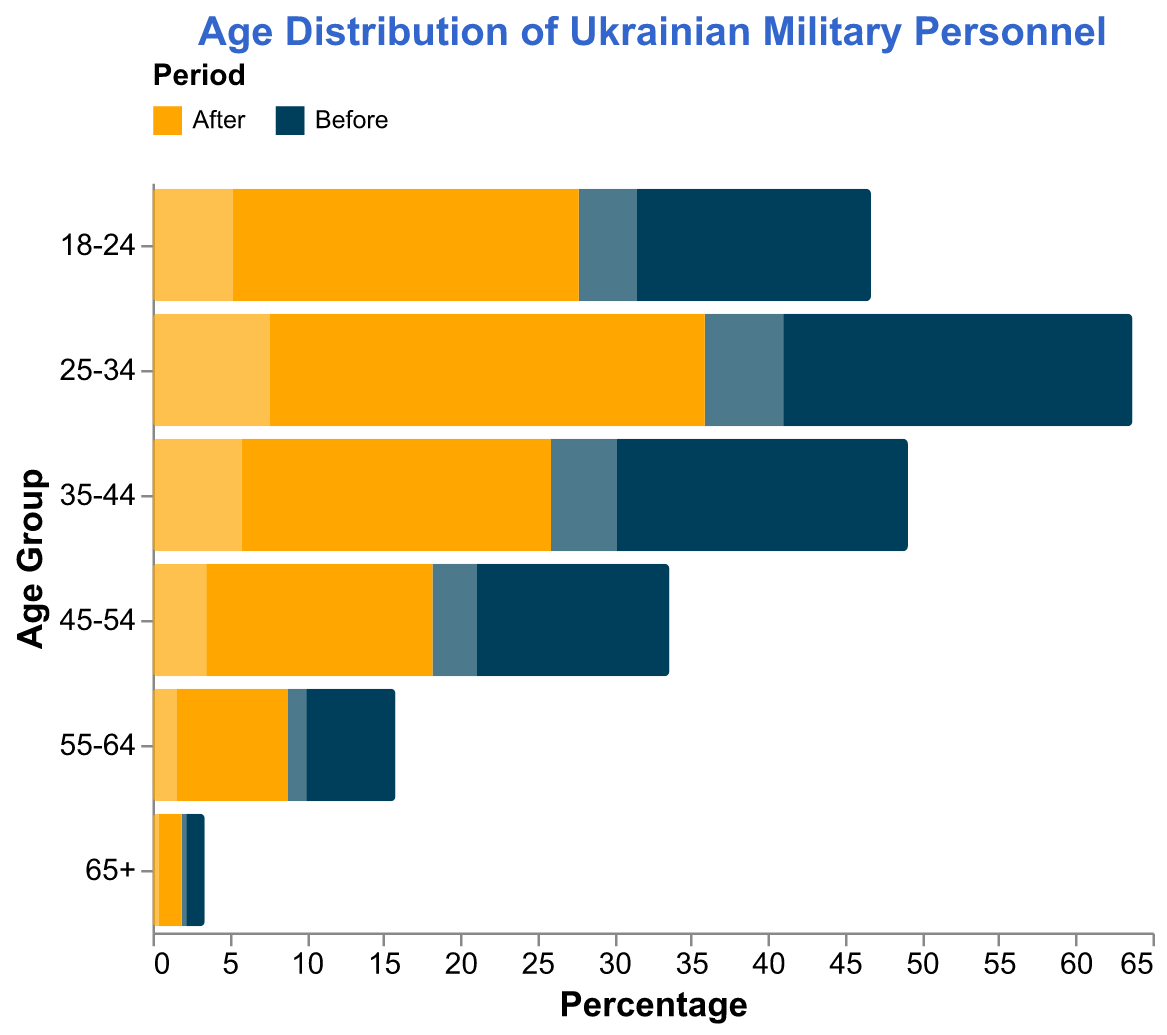What is the title of the plot? The title of the plot is displayed at the top and reads "Age Distribution of Ukrainian Military Personnel."
Answer: Age Distribution of Ukrainian Military Personnel Which age group has the highest percentage of males after the recent conflict? By comparing the lengths of the bars representing males after the conflict, the age group "25-34" has the highest percentage at -28.3.
Answer: 25-34 What percentage of females were in the 18-24 age group before the recent conflict? The bar representing females in the 18-24 age group before the conflict shows a percentage of 3.8.
Answer: 3.8 How did the percentage of males in the 55-64 age group change after the recent conflict? Comparing the lengths of the bars for males in the 55-64 age group before and after the conflict, the percentage increased from -5.8 to -7.2. The change is -7.2 - (-5.8) = -1.4.
Answer: Increased by 1.4 Which period has a higher percentage of females in the 35-44 age group? The lengths of the bars representing females in the 35-44 age group for both periods indicate that the percentage is higher after the recent conflict (5.8) than before (4.3).
Answer: After What is the total percentage of all age groups combined for females after the conflict? Summing the percentages for females in all age groups after the conflict: 5.2 + 7.6 + 5.8 + 3.5 + 1.6 + 0.4 = 24.1
Answer: 24.1 Which gender and period have the lowest percentage in the 65+ age group? The bars representing the 65+ age group show that males before the conflict have the lowest percentage at -1.2.
Answer: Males Before How does the overall trend of age distribution for both males and females change after the recent conflict compared to before? Reviewing the bars across all age groups, the general trend shows an increase in the percentage of younger (18-34) military personnel for both genders after the conflict, while the older age groups show less significant increases or small changes.
Answer: Increase in younger age groups Which age group shows the smallest change in females' percentage from before to after the recent conflict? By calculating the differences in percentages for each age group for females, the 45-54 age group has the smallest change: 3.5 - 2.9 = 0.6.
Answer: 45-54 